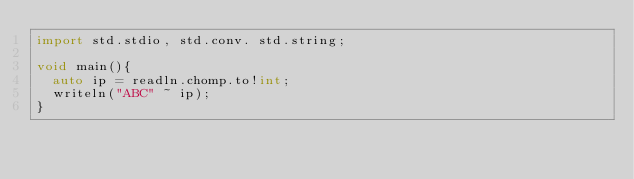<code> <loc_0><loc_0><loc_500><loc_500><_D_>import std.stdio, std.conv. std.string;

void main(){
  auto ip = readln.chomp.to!int;
  writeln("ABC" ~ ip);
}</code> 